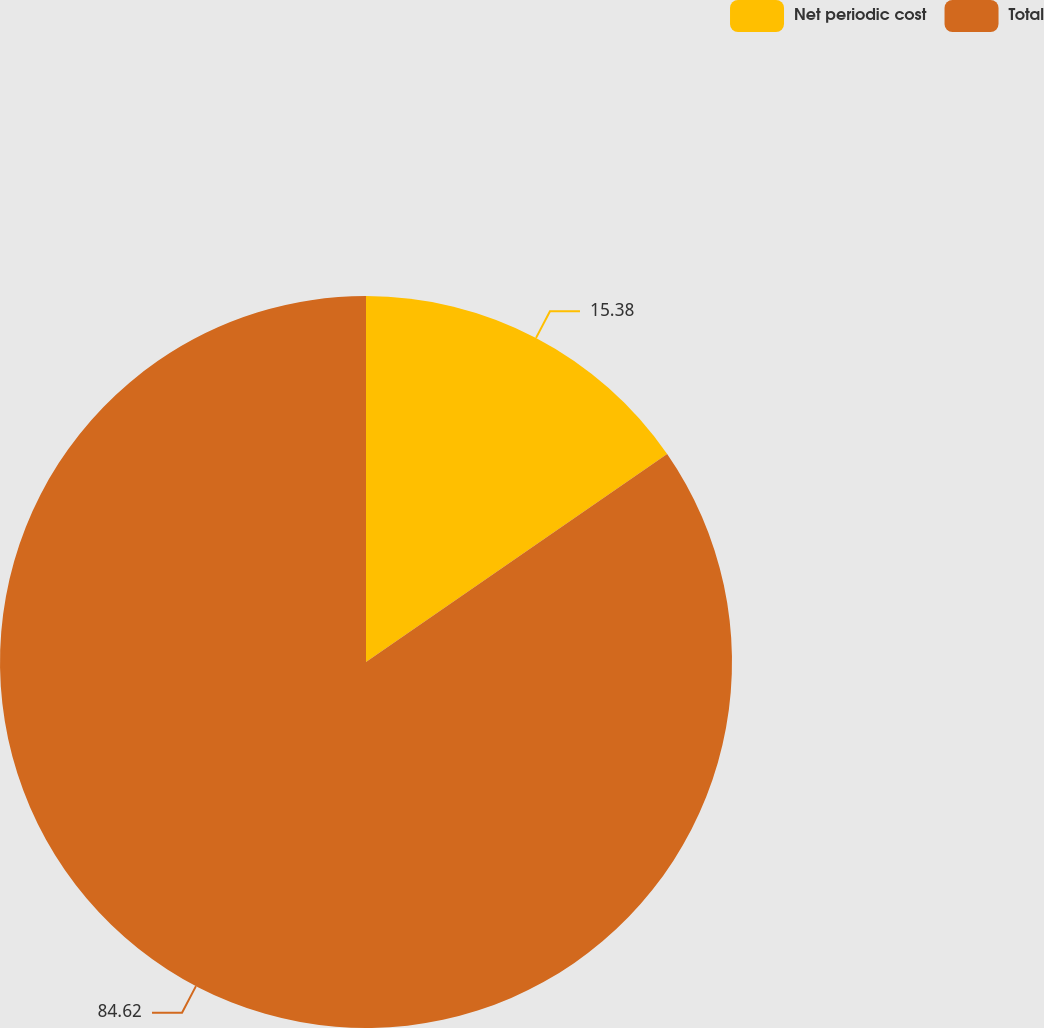Convert chart. <chart><loc_0><loc_0><loc_500><loc_500><pie_chart><fcel>Net periodic cost<fcel>Total<nl><fcel>15.38%<fcel>84.62%<nl></chart> 